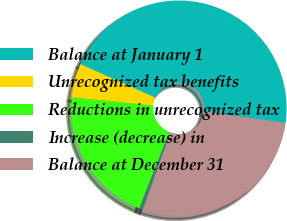Convert chart. <chart><loc_0><loc_0><loc_500><loc_500><pie_chart><fcel>Balance at January 1<fcel>Unrecognized tax benefits<fcel>Reductions in unrecognized tax<fcel>Increase (decrease) in<fcel>Balance at December 31<nl><fcel>45.5%<fcel>5.09%<fcel>20.59%<fcel>0.6%<fcel>28.22%<nl></chart> 